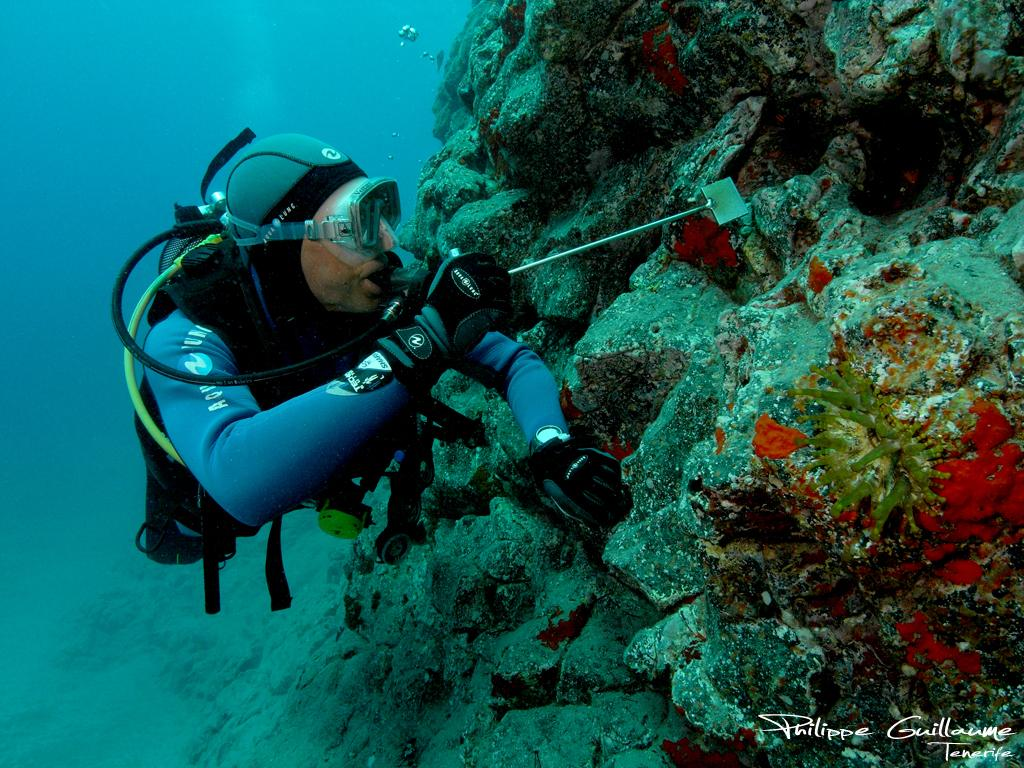What is the main subject in the foreground of the image? There is a man in the foreground of the image. What activity is the man engaged in? The man is doing scuba diving underwater. What object is the man holding in his hand? The man is holding a spatula in his hand. What can be seen on the right side of the image? There are rocks on the right side of the image. What type of vegetation is visible underwater? There are plants visible underwater. What type of haircut is the man getting while scuba diving? There is no haircut or barber present in the image; the man is scuba diving underwater. What type of oil can be seen floating on the water in the image? There is no oil visible in the image; the focus is on the man scuba diving and the underwater environment. 